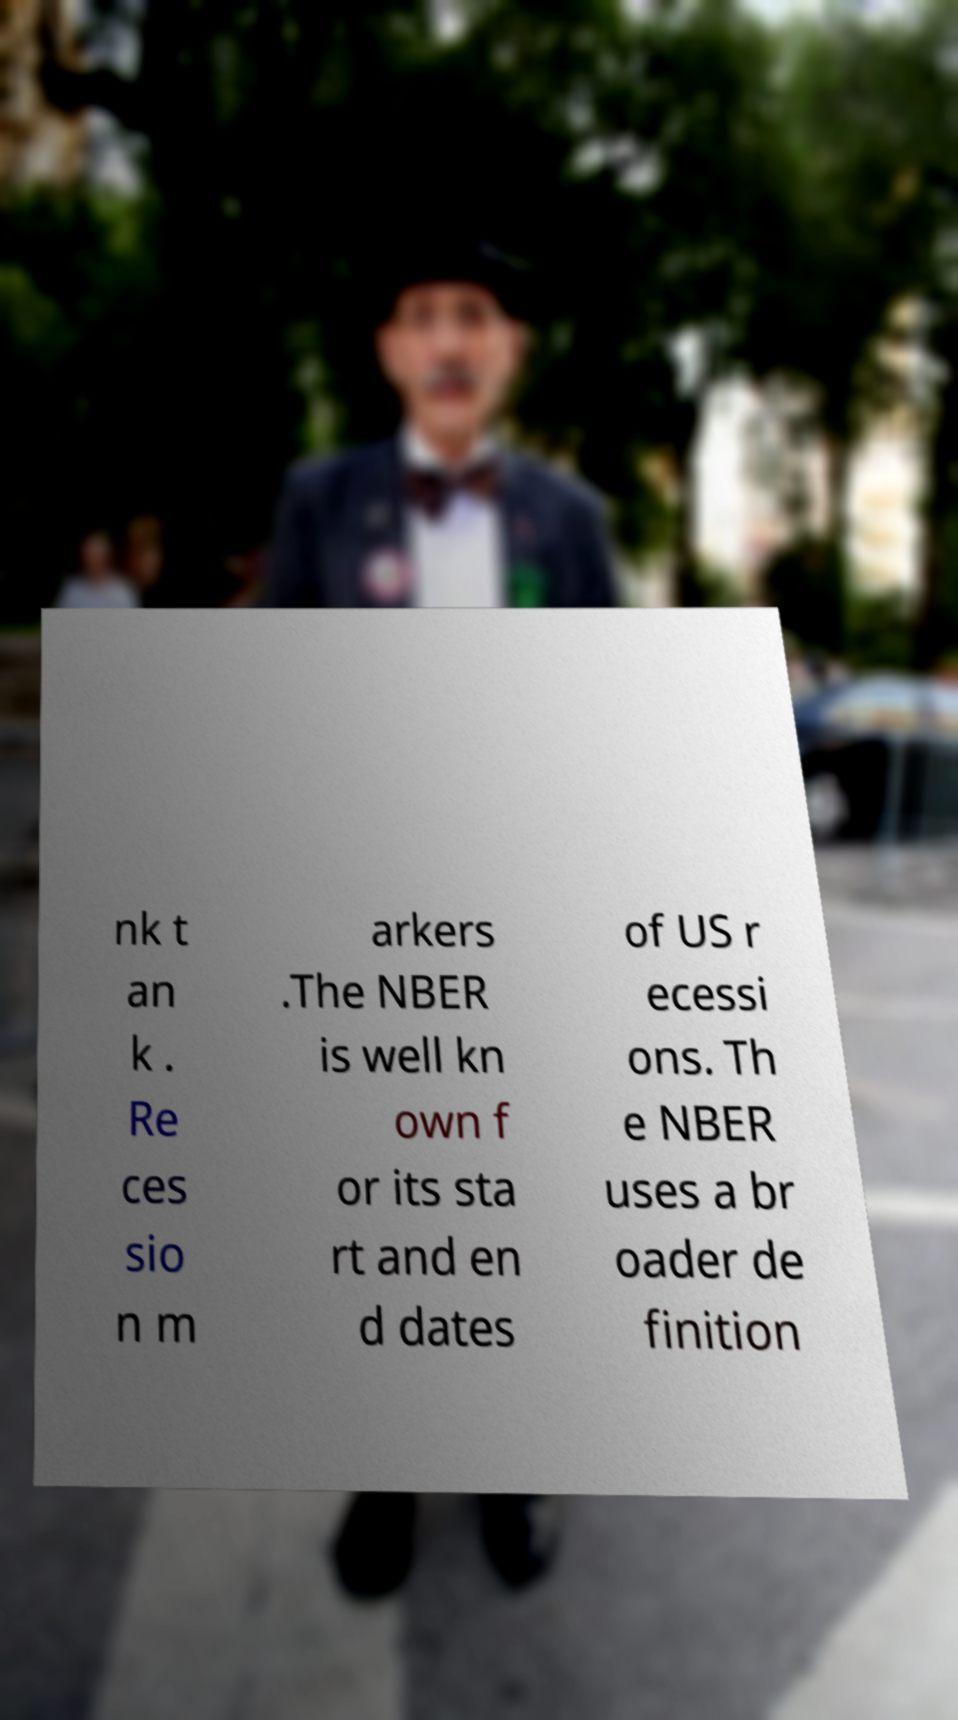Can you accurately transcribe the text from the provided image for me? nk t an k . Re ces sio n m arkers .The NBER is well kn own f or its sta rt and en d dates of US r ecessi ons. Th e NBER uses a br oader de finition 